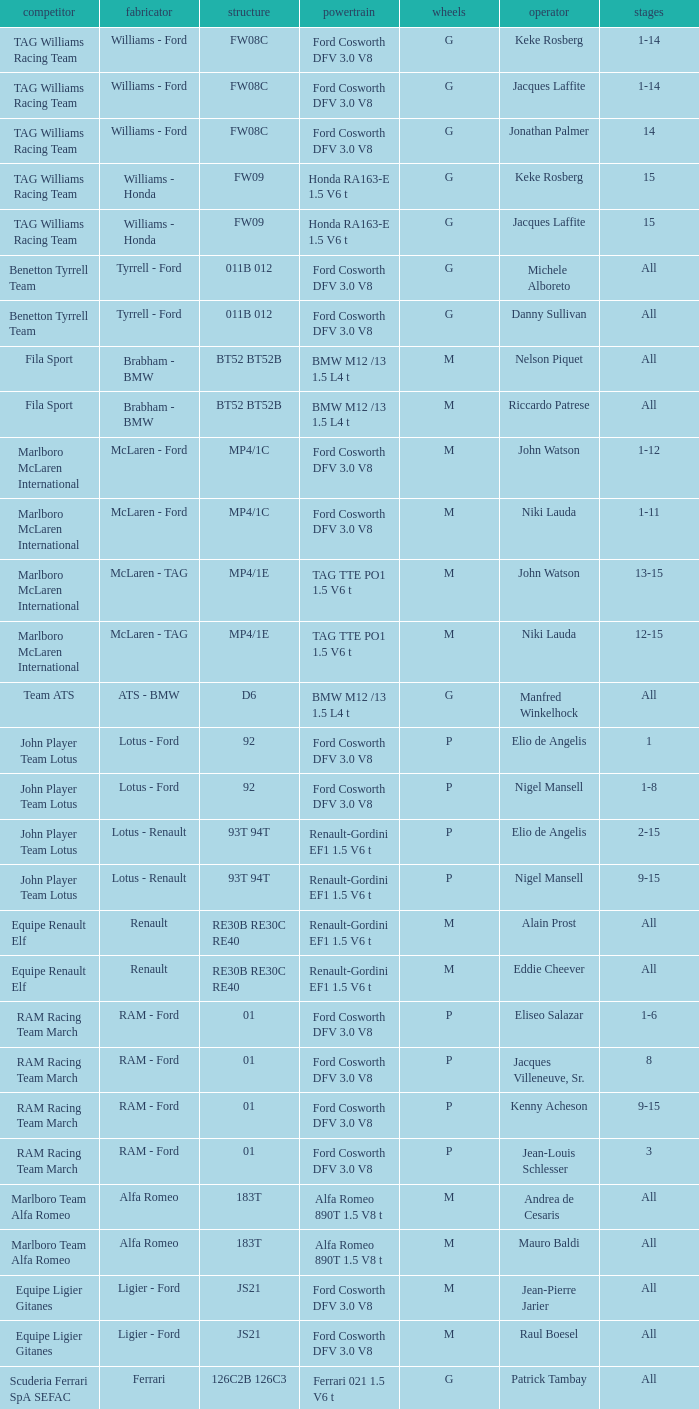Who is the constructor for driver Niki Lauda and a chassis of mp4/1c? McLaren - Ford. 